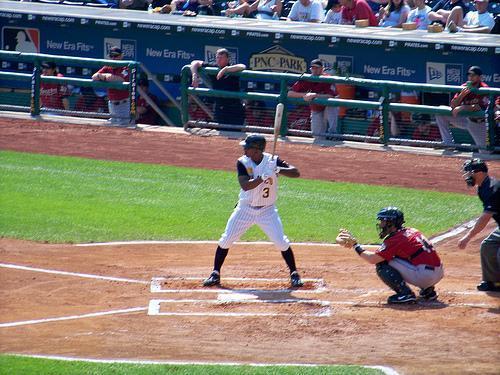How many people are playing football?
Give a very brief answer. 0. 